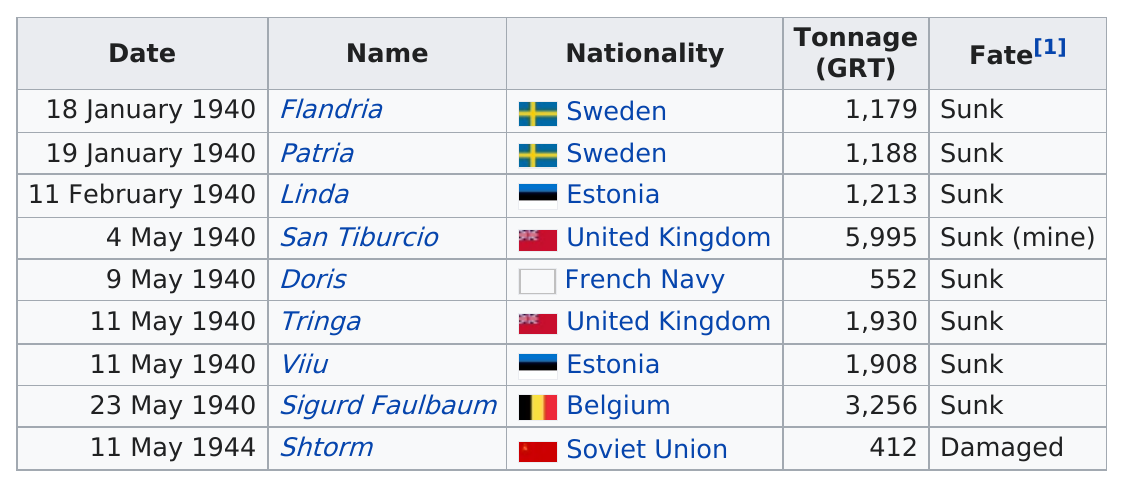Indicate a few pertinent items in this graphic. On September 28, 1941, two nationalities with a tonnage of around 1900 each, the United Kingdom and Estonia, were forced to surrender to the USSR and Germany respectively after both ships were sunk in separate incidents. On May 11, 1940, the total number of ships that sank was two. The United Kingdom is on top of the French Navy. The submarine named "Storm" did not sink. In May, more vessels were reported lost than in January. 